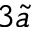<formula> <loc_0><loc_0><loc_500><loc_500>3 \tilde { a }</formula> 